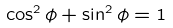<formula> <loc_0><loc_0><loc_500><loc_500>\cos ^ { 2 } \phi + \sin ^ { 2 } \phi = 1</formula> 